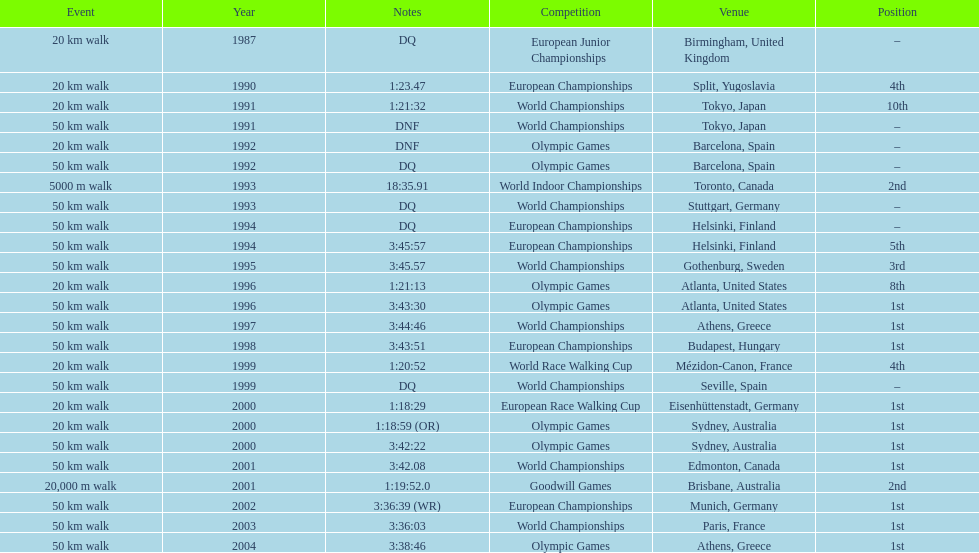How many times did korzeniowski finish above fourth place? 13. 